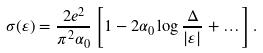<formula> <loc_0><loc_0><loc_500><loc_500>\sigma ( \varepsilon ) = \frac { 2 e ^ { 2 } } { \pi ^ { 2 } \alpha _ { 0 } } \left [ 1 - 2 \alpha _ { 0 } \log \frac { \Delta } { | \varepsilon | } + \dots \right ] .</formula> 